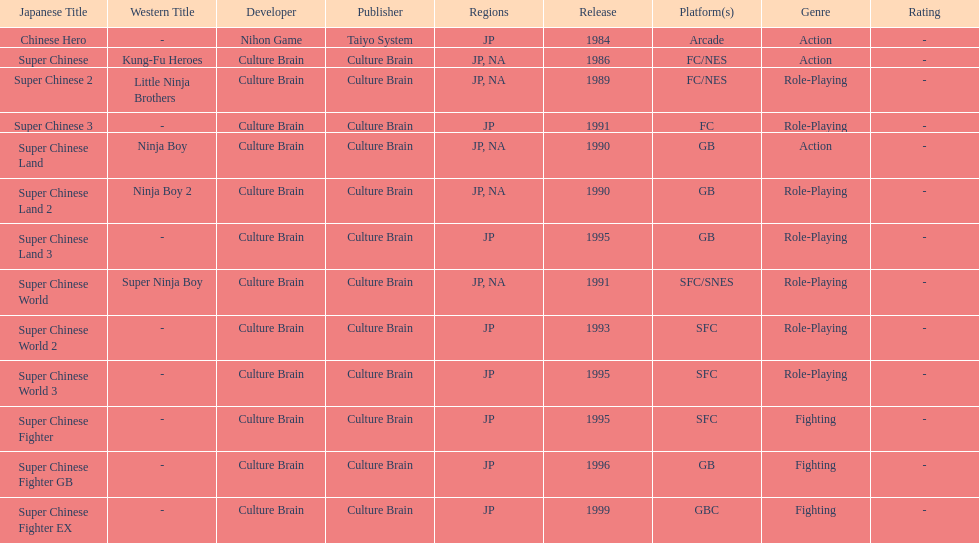The first year a game was released in north america 1986. 